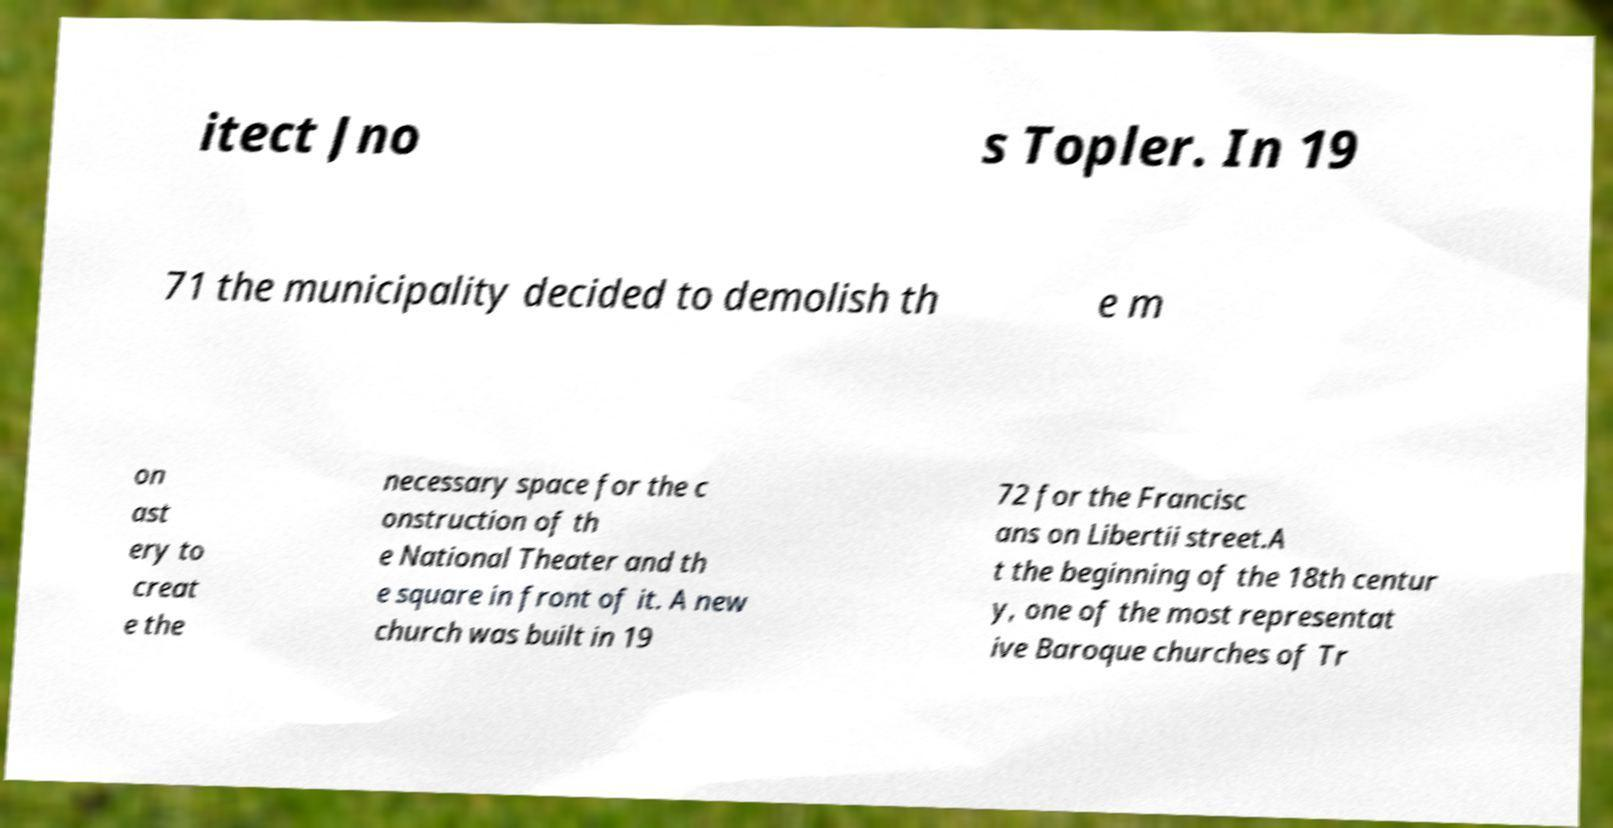Please read and relay the text visible in this image. What does it say? itect Jno s Topler. In 19 71 the municipality decided to demolish th e m on ast ery to creat e the necessary space for the c onstruction of th e National Theater and th e square in front of it. A new church was built in 19 72 for the Francisc ans on Libertii street.A t the beginning of the 18th centur y, one of the most representat ive Baroque churches of Tr 